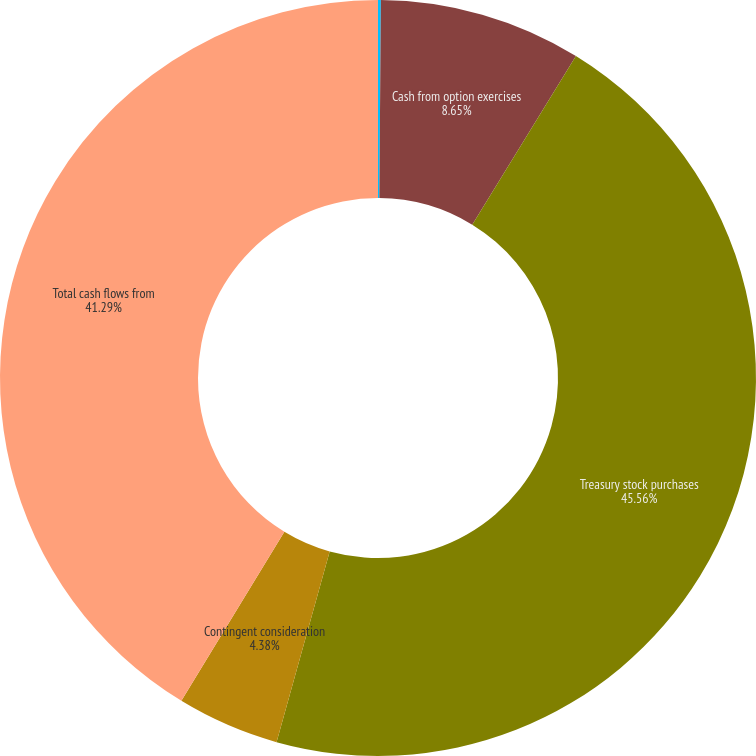<chart> <loc_0><loc_0><loc_500><loc_500><pie_chart><fcel>(In thousands)<fcel>Cash from option exercises<fcel>Treasury stock purchases<fcel>Contingent consideration<fcel>Total cash flows from<nl><fcel>0.12%<fcel>8.65%<fcel>45.55%<fcel>4.38%<fcel>41.29%<nl></chart> 